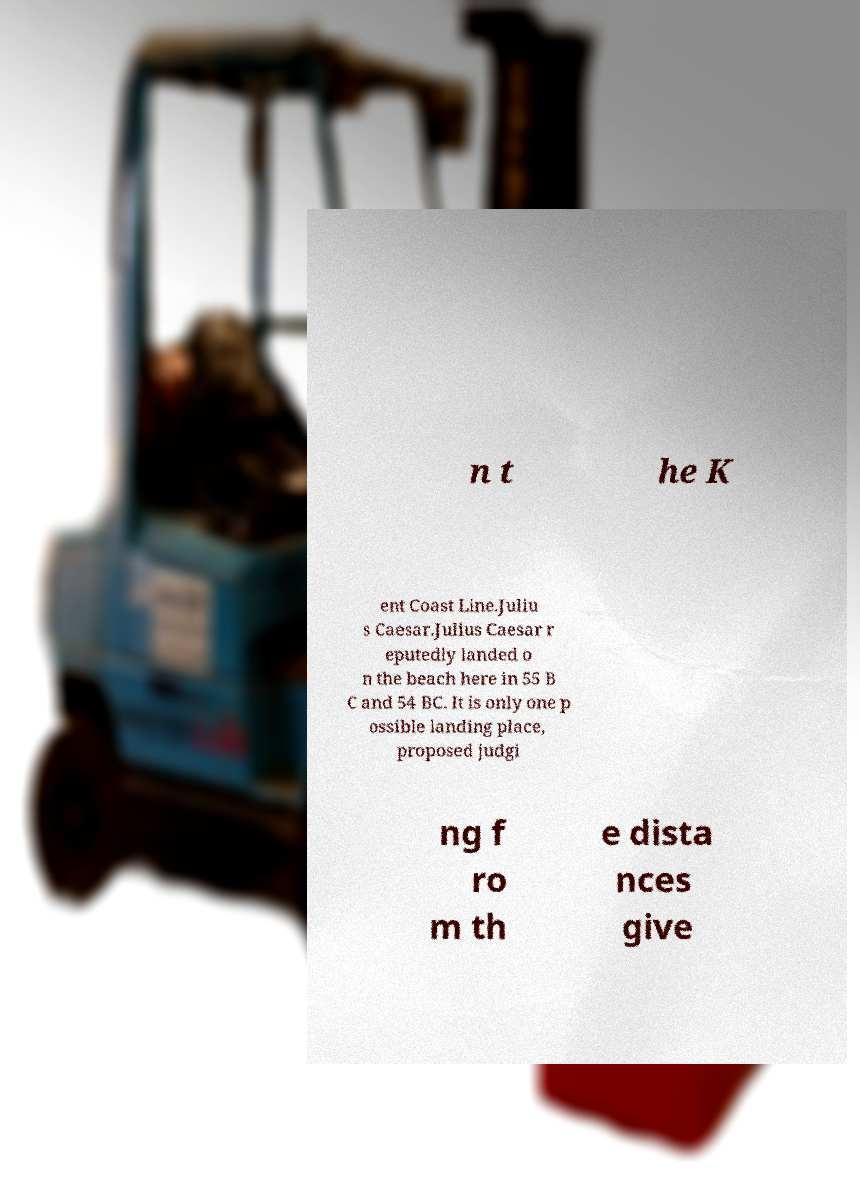For documentation purposes, I need the text within this image transcribed. Could you provide that? n t he K ent Coast Line.Juliu s Caesar.Julius Caesar r eputedly landed o n the beach here in 55 B C and 54 BC. It is only one p ossible landing place, proposed judgi ng f ro m th e dista nces give 